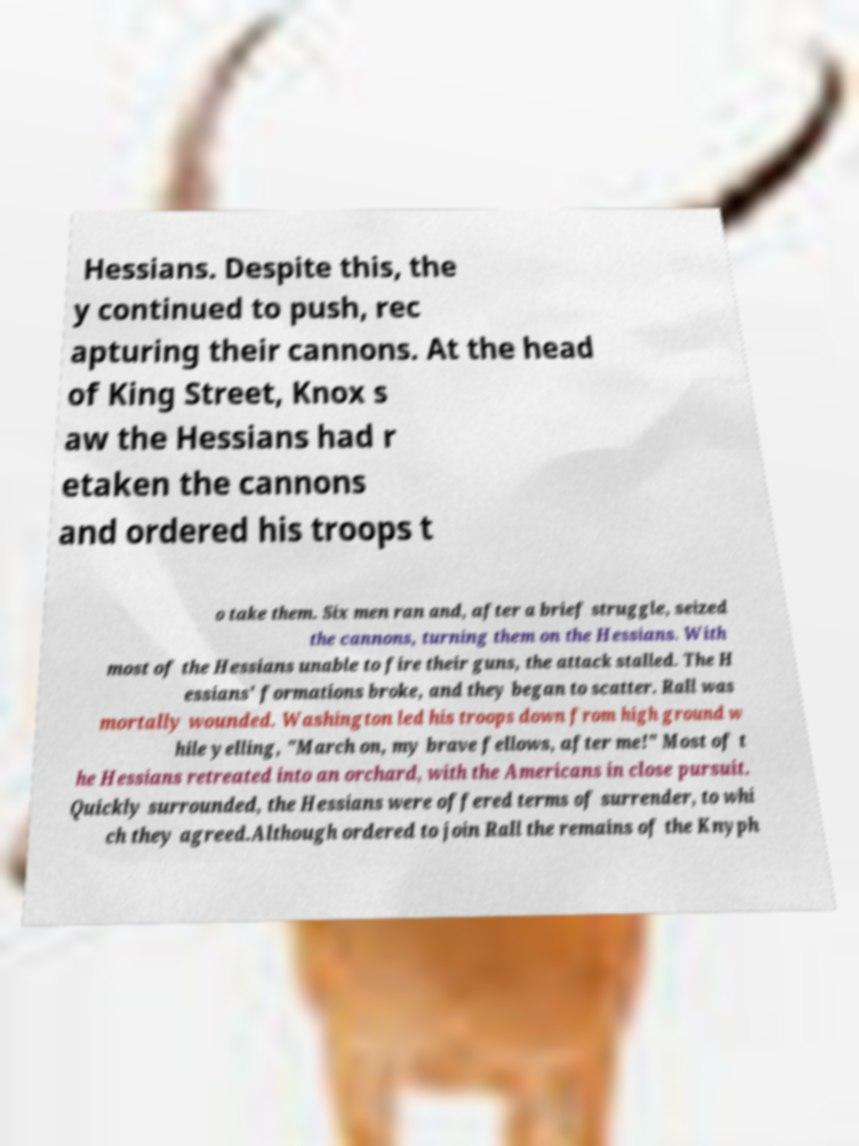Please identify and transcribe the text found in this image. Hessians. Despite this, the y continued to push, rec apturing their cannons. At the head of King Street, Knox s aw the Hessians had r etaken the cannons and ordered his troops t o take them. Six men ran and, after a brief struggle, seized the cannons, turning them on the Hessians. With most of the Hessians unable to fire their guns, the attack stalled. The H essians' formations broke, and they began to scatter. Rall was mortally wounded. Washington led his troops down from high ground w hile yelling, "March on, my brave fellows, after me!" Most of t he Hessians retreated into an orchard, with the Americans in close pursuit. Quickly surrounded, the Hessians were offered terms of surrender, to whi ch they agreed.Although ordered to join Rall the remains of the Knyph 